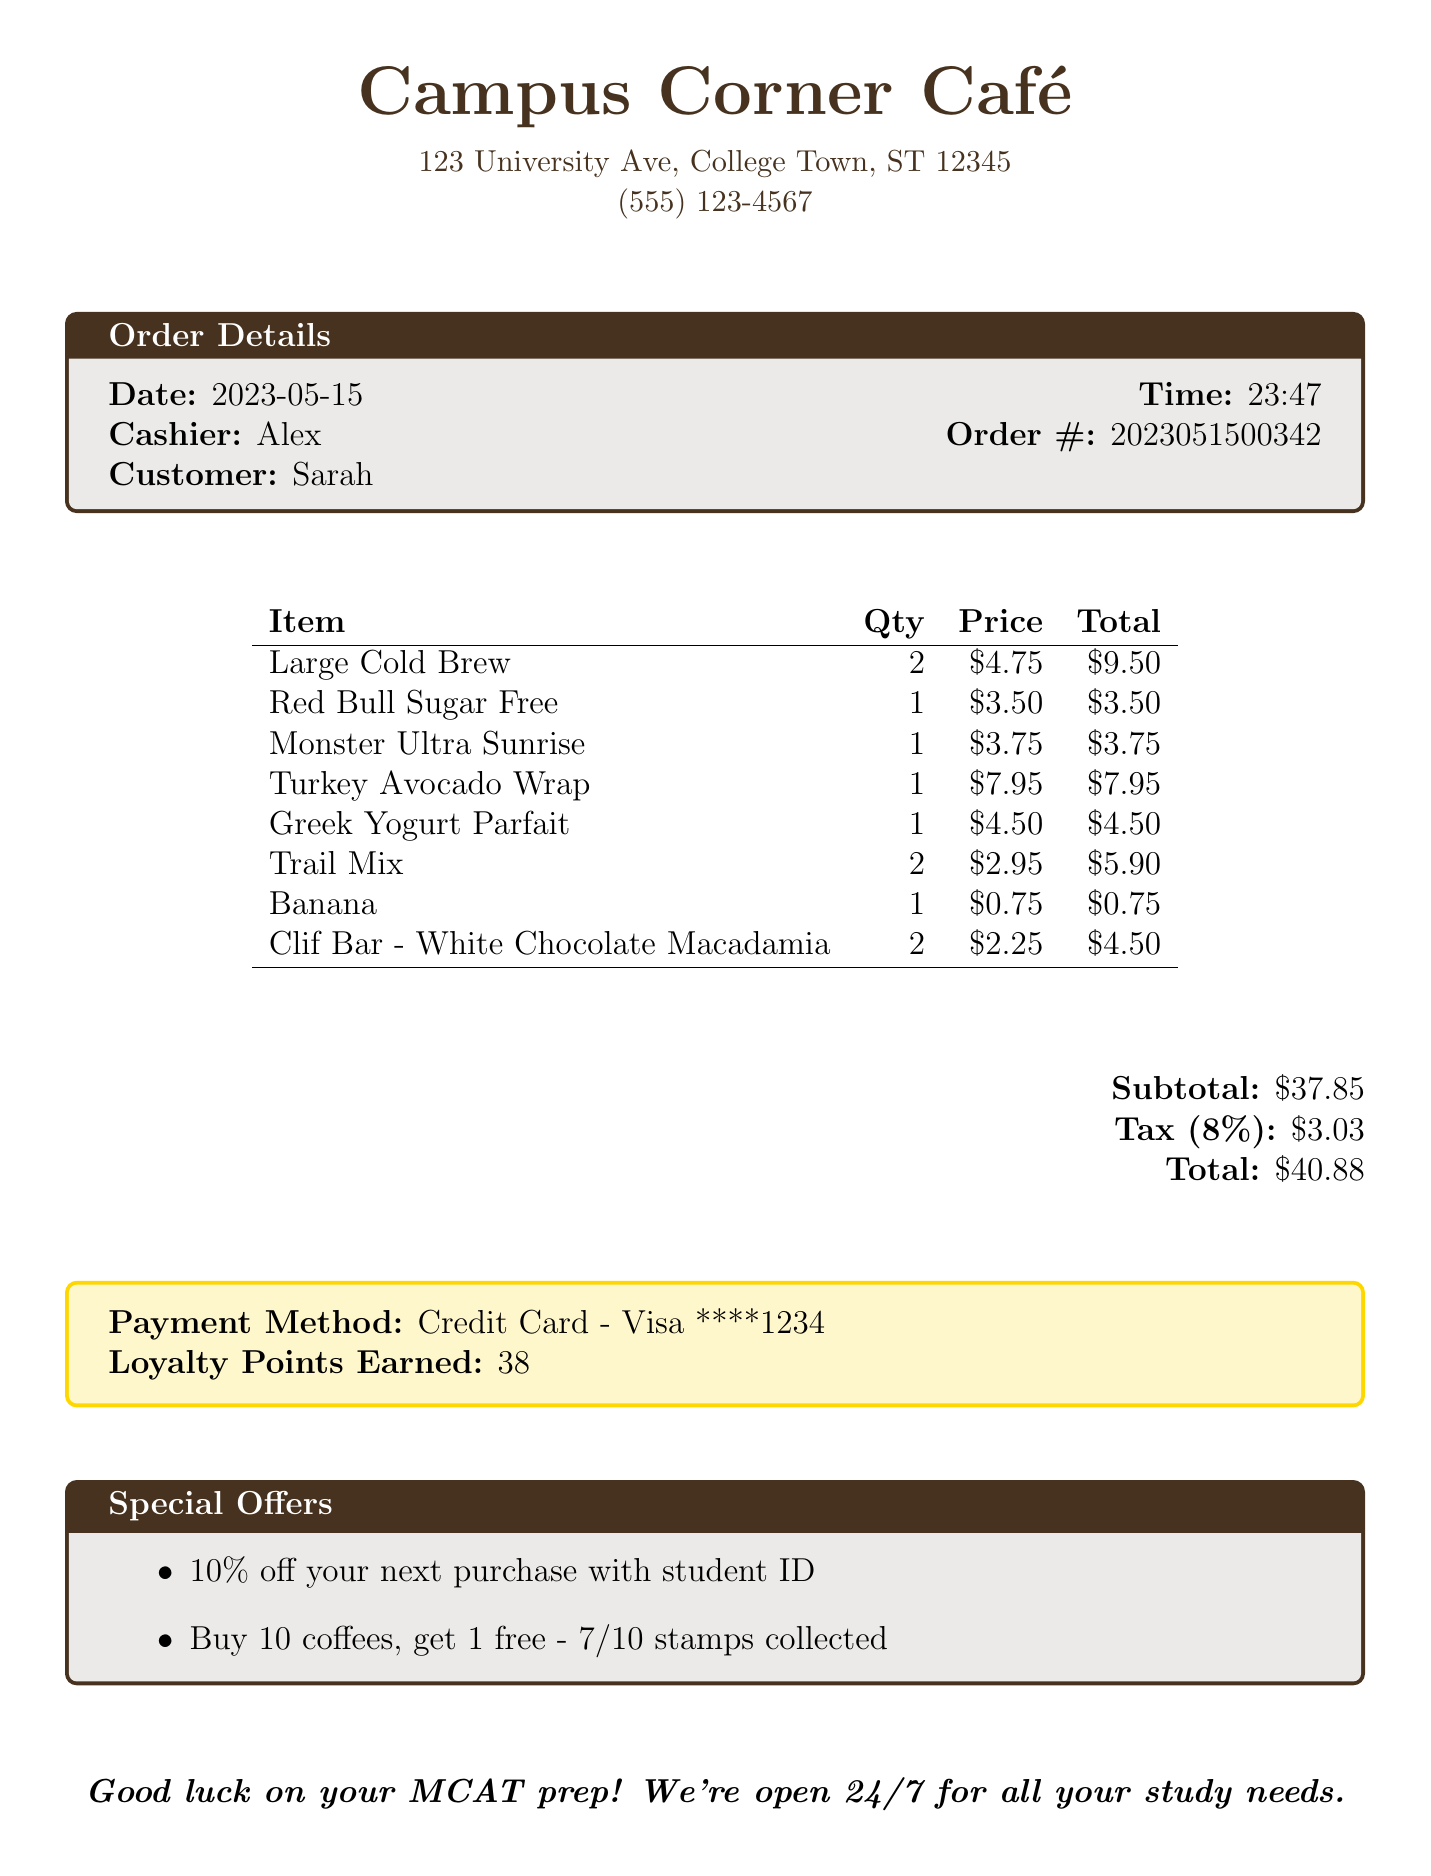What is the store name? The store name is clearly stated at the top of the receipt.
Answer: Campus Corner Café What is the date of the purchase? The purchase date is included in the order details section.
Answer: 2023-05-15 Who was the cashier? The cashier's name is mentioned in the order details section.
Answer: Alex What items were purchased? The items purchased are listed in the table with their names.
Answer: Large Cold Brew, Red Bull Sugar Free, Monster Ultra Sunrise, Turkey Avocado Wrap, Greek Yogurt Parfait, Trail Mix, Banana, Clif Bar - White Chocolate Macadamia What was the total amount spent? The total amount is summarized at the bottom of the receipt.
Answer: $40.88 How many loyalty points were earned? The loyalty points earned are shown in the payment method section.
Answer: 38 What offers can the customer use for their next purchase? The special offers are listed in their own section on the receipt.
Answer: 10% off your next purchase with student ID, Buy 10 coffees, get 1 free What time was the order placed? The order time is provided in the order details section.
Answer: 23:47 What payment method was used? The payment method is stated clearly in the receipt.
Answer: Credit Card - Visa ****1234 